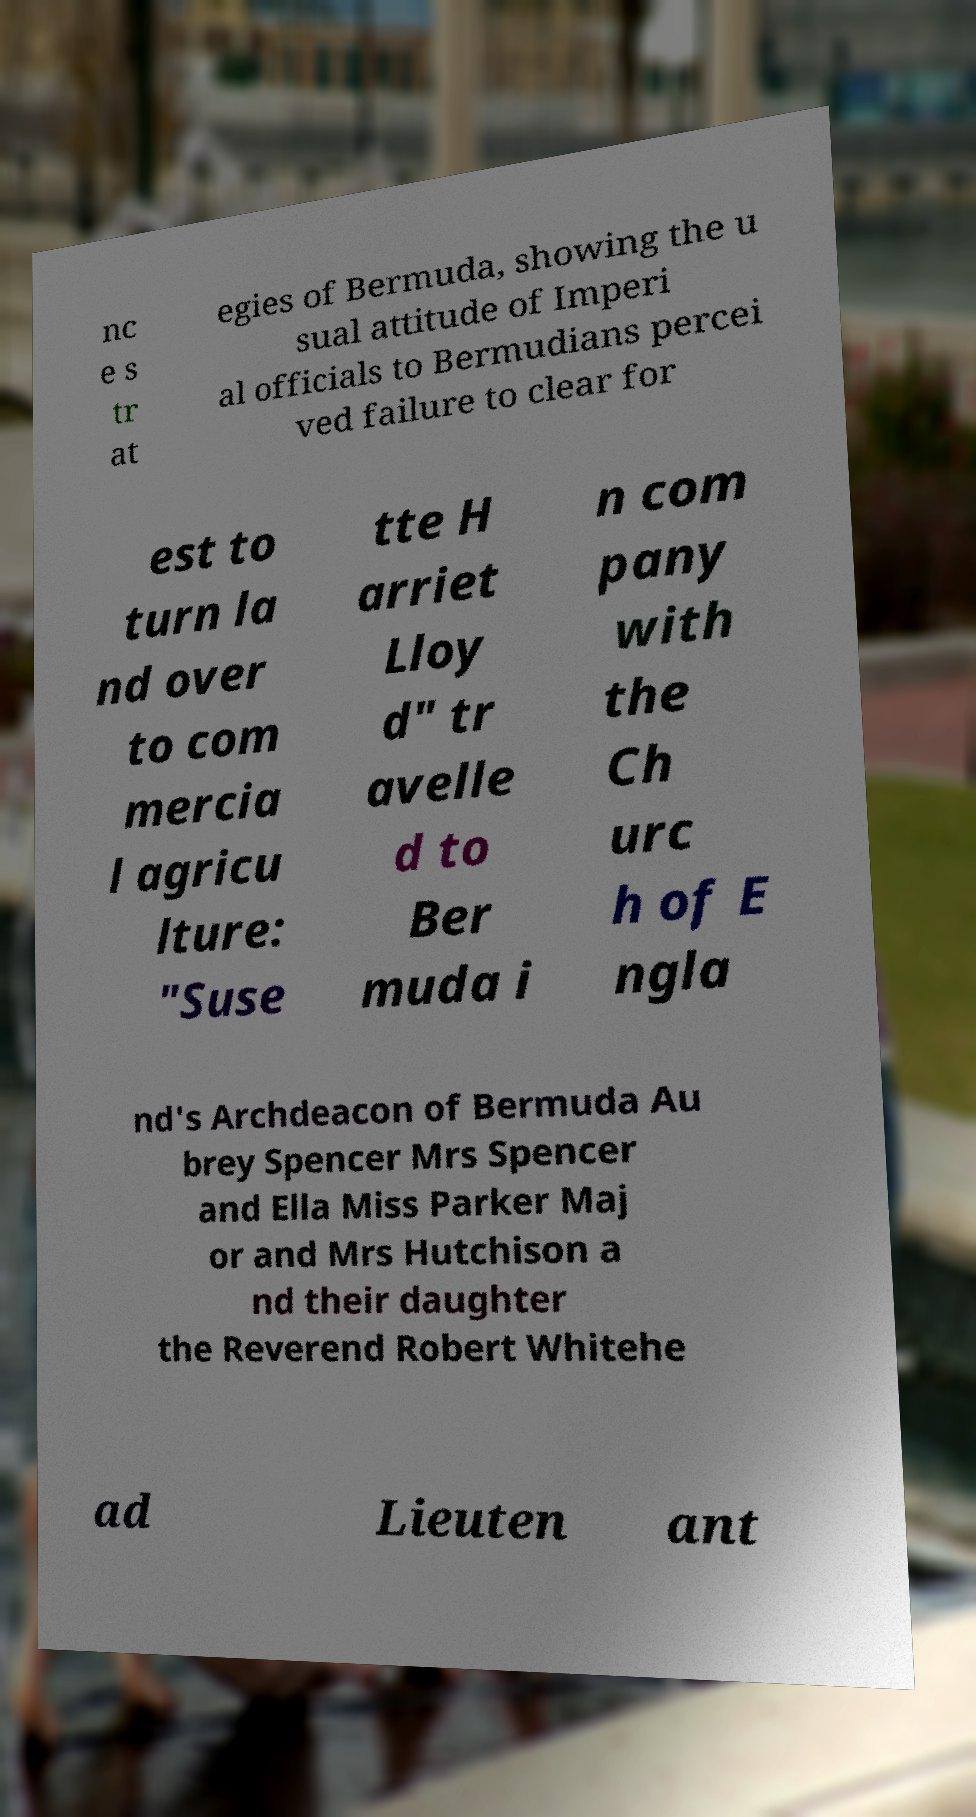Could you assist in decoding the text presented in this image and type it out clearly? nc e s tr at egies of Bermuda, showing the u sual attitude of Imperi al officials to Bermudians percei ved failure to clear for est to turn la nd over to com mercia l agricu lture: "Suse tte H arriet Lloy d" tr avelle d to Ber muda i n com pany with the Ch urc h of E ngla nd's Archdeacon of Bermuda Au brey Spencer Mrs Spencer and Ella Miss Parker Maj or and Mrs Hutchison a nd their daughter the Reverend Robert Whitehe ad Lieuten ant 